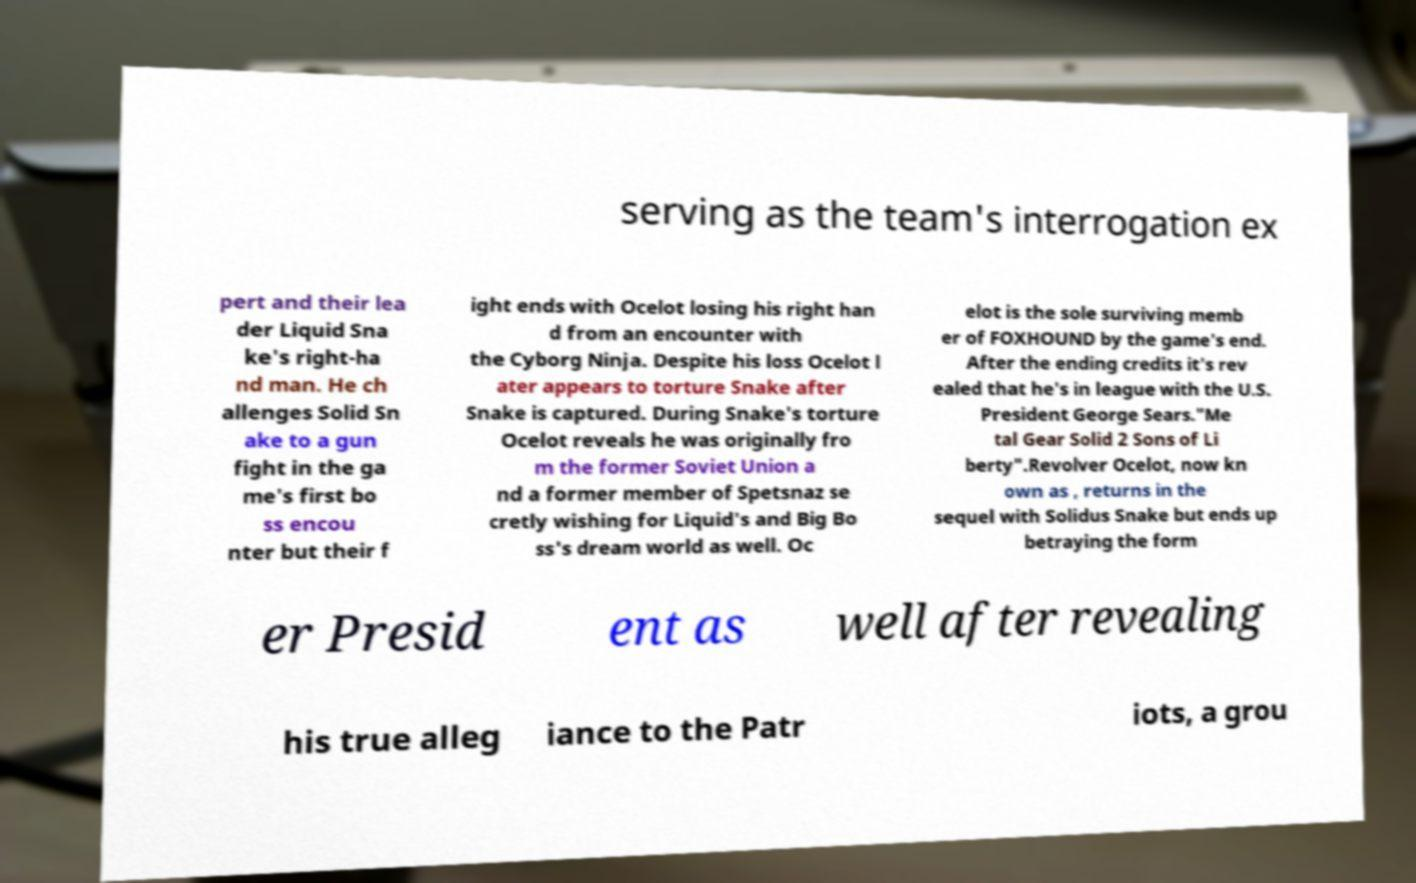Can you read and provide the text displayed in the image?This photo seems to have some interesting text. Can you extract and type it out for me? serving as the team's interrogation ex pert and their lea der Liquid Sna ke's right-ha nd man. He ch allenges Solid Sn ake to a gun fight in the ga me's first bo ss encou nter but their f ight ends with Ocelot losing his right han d from an encounter with the Cyborg Ninja. Despite his loss Ocelot l ater appears to torture Snake after Snake is captured. During Snake's torture Ocelot reveals he was originally fro m the former Soviet Union a nd a former member of Spetsnaz se cretly wishing for Liquid's and Big Bo ss's dream world as well. Oc elot is the sole surviving memb er of FOXHOUND by the game's end. After the ending credits it's rev ealed that he's in league with the U.S. President George Sears."Me tal Gear Solid 2 Sons of Li berty".Revolver Ocelot, now kn own as , returns in the sequel with Solidus Snake but ends up betraying the form er Presid ent as well after revealing his true alleg iance to the Patr iots, a grou 